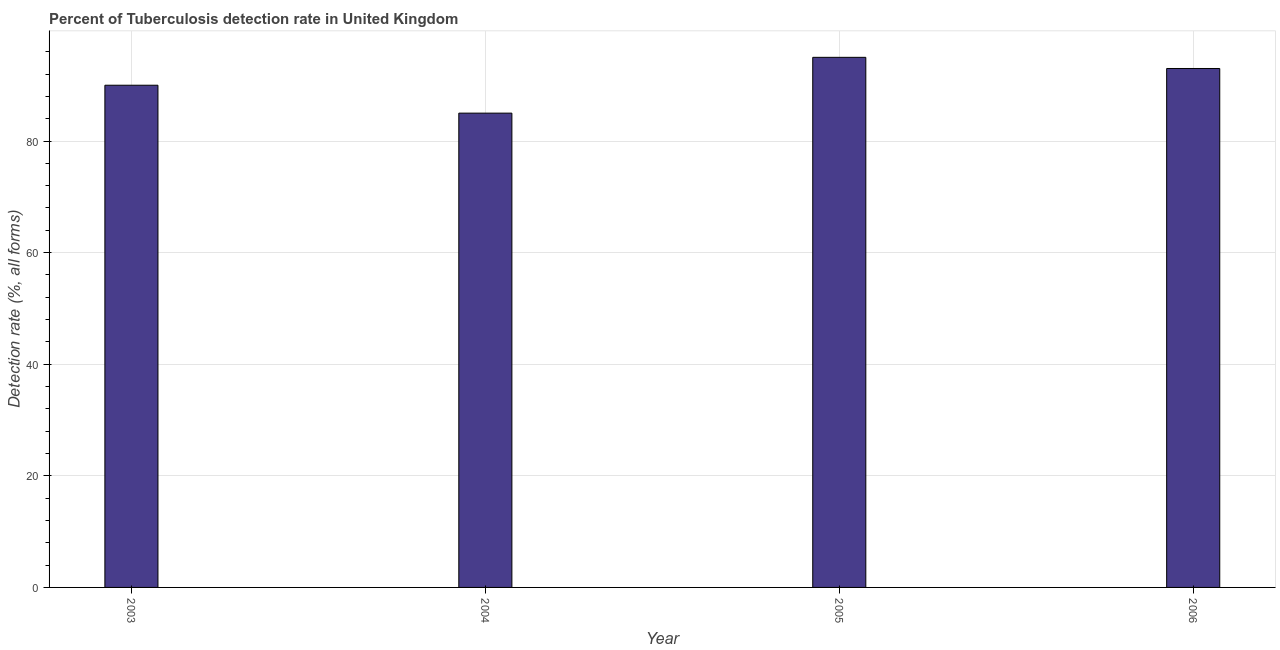Does the graph contain grids?
Provide a short and direct response. Yes. What is the title of the graph?
Keep it short and to the point. Percent of Tuberculosis detection rate in United Kingdom. What is the label or title of the Y-axis?
Your answer should be very brief. Detection rate (%, all forms). Across all years, what is the maximum detection rate of tuberculosis?
Keep it short and to the point. 95. Across all years, what is the minimum detection rate of tuberculosis?
Your answer should be very brief. 85. In which year was the detection rate of tuberculosis minimum?
Your answer should be compact. 2004. What is the sum of the detection rate of tuberculosis?
Provide a short and direct response. 363. What is the difference between the detection rate of tuberculosis in 2003 and 2004?
Make the answer very short. 5. What is the median detection rate of tuberculosis?
Make the answer very short. 91.5. What is the ratio of the detection rate of tuberculosis in 2004 to that in 2006?
Your answer should be very brief. 0.91. Is the difference between the detection rate of tuberculosis in 2003 and 2004 greater than the difference between any two years?
Your answer should be very brief. No. What is the difference between the highest and the lowest detection rate of tuberculosis?
Provide a succinct answer. 10. In how many years, is the detection rate of tuberculosis greater than the average detection rate of tuberculosis taken over all years?
Make the answer very short. 2. How many bars are there?
Provide a short and direct response. 4. Are all the bars in the graph horizontal?
Provide a succinct answer. No. How many years are there in the graph?
Offer a very short reply. 4. What is the difference between two consecutive major ticks on the Y-axis?
Your answer should be compact. 20. Are the values on the major ticks of Y-axis written in scientific E-notation?
Ensure brevity in your answer.  No. What is the Detection rate (%, all forms) of 2003?
Offer a very short reply. 90. What is the Detection rate (%, all forms) of 2004?
Keep it short and to the point. 85. What is the Detection rate (%, all forms) in 2005?
Provide a succinct answer. 95. What is the Detection rate (%, all forms) of 2006?
Provide a short and direct response. 93. What is the difference between the Detection rate (%, all forms) in 2003 and 2004?
Provide a succinct answer. 5. What is the difference between the Detection rate (%, all forms) in 2003 and 2006?
Offer a very short reply. -3. What is the difference between the Detection rate (%, all forms) in 2005 and 2006?
Provide a succinct answer. 2. What is the ratio of the Detection rate (%, all forms) in 2003 to that in 2004?
Your answer should be compact. 1.06. What is the ratio of the Detection rate (%, all forms) in 2003 to that in 2005?
Make the answer very short. 0.95. What is the ratio of the Detection rate (%, all forms) in 2003 to that in 2006?
Your response must be concise. 0.97. What is the ratio of the Detection rate (%, all forms) in 2004 to that in 2005?
Provide a succinct answer. 0.9. What is the ratio of the Detection rate (%, all forms) in 2004 to that in 2006?
Give a very brief answer. 0.91. 